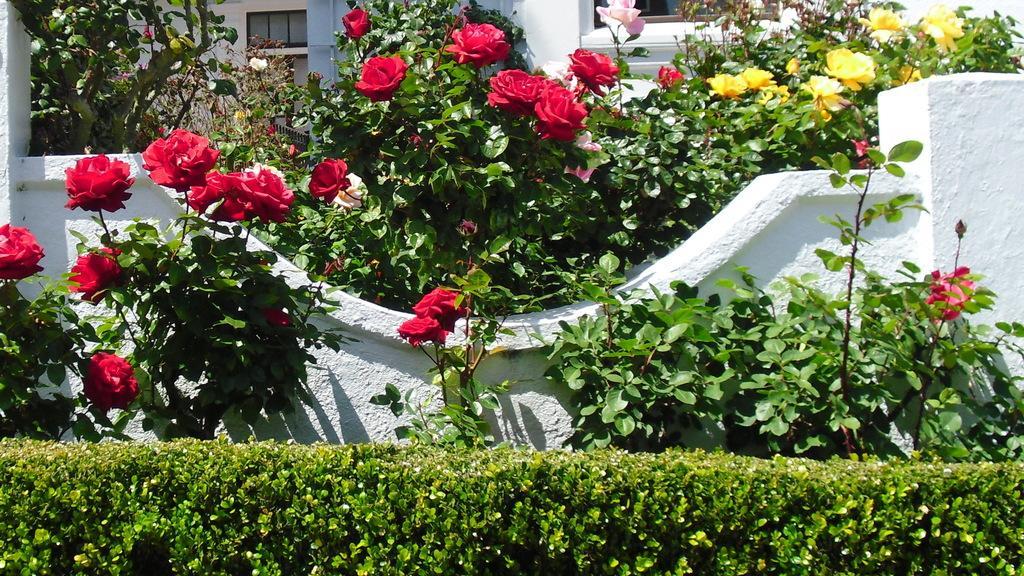In one or two sentences, can you explain what this image depicts? There are plants planted in a row. In background, there are plants having flowers near white wall. Outside this wall, there are other plants which are having flowers in different colors and there is a white color building which is having glass windows. 